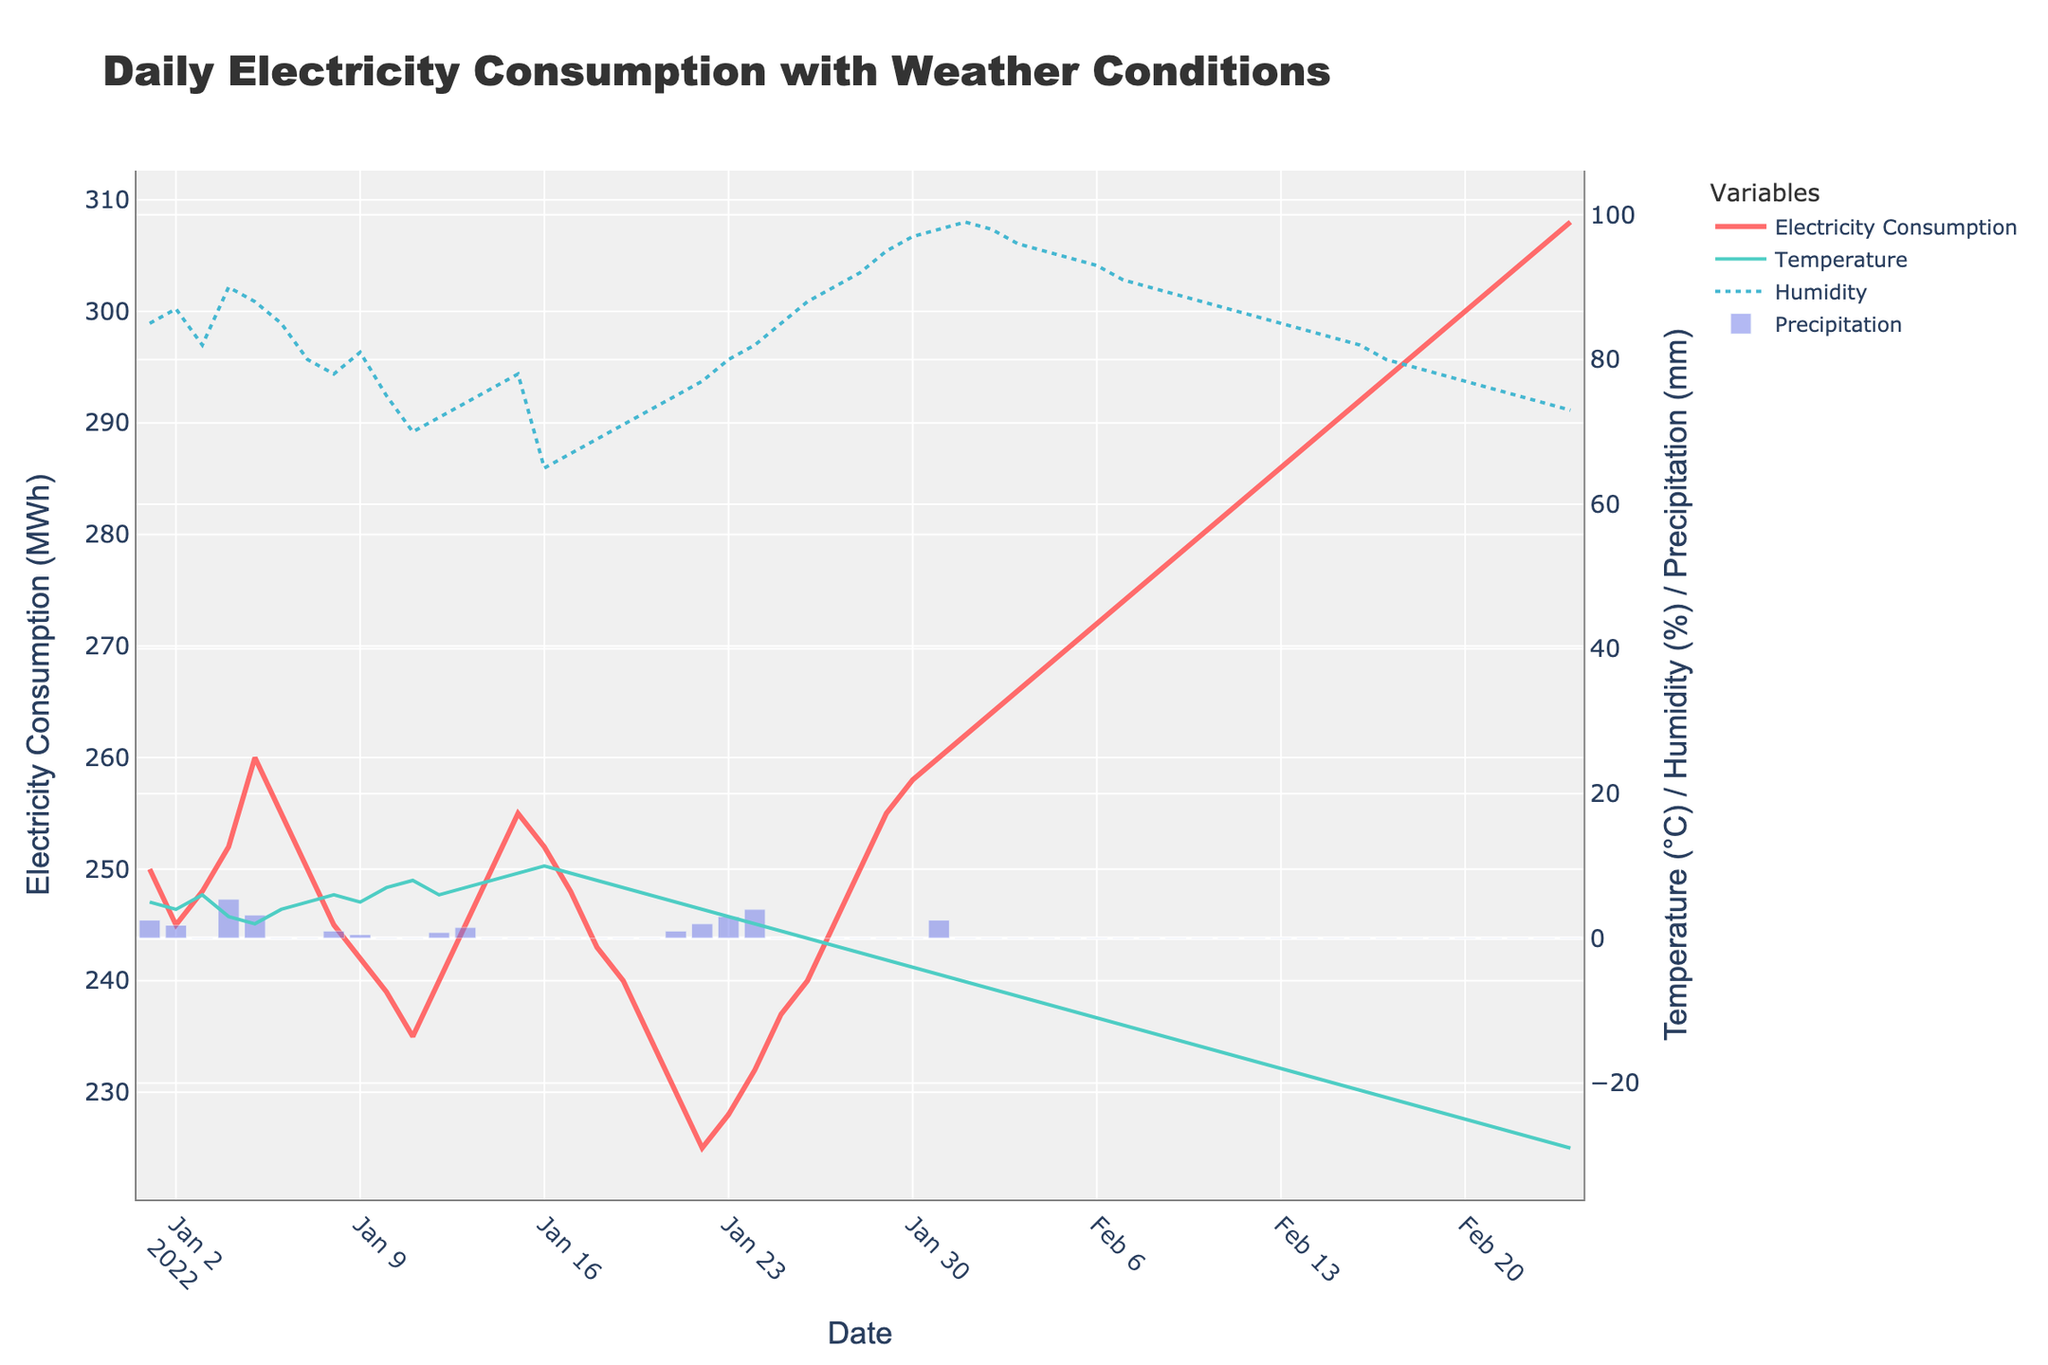What is the title of the plot? The plot's title is usually located at the top and is larger or bolded compared to other text. The title for this figure is clearly stated at the top.
Answer: Daily Electricity Consumption with Weather Conditions Which variable has a line color in red? The variable with the red line color is "Electricity Consumption," which can be identified by looking at the legend or associating the line color with the variable name in the figure.
Answer: Electricity Consumption How does electricity consumption change with temperature trends from January to February? Analyze the line for electricity consumption (red) and compare it with the temperature (green) trend line. As the temperature drops from January to February, the electricity consumption steadily increases.
Answer: Inversely related What days had the highest electricity consumption? Locate the specific points on the "Electricity Consumption" red line that peak. The highest peaks are observed in early February around the 8th and 15th.
Answer: Early February (around the 8th and 15th) What is the overall trend of humidity over the time period? Examine the dotted blue line representing humidity across the timeline from January to February. Humidity generally decreases from around 90% in January to about 75% or lower by mid-February.
Answer: Decreasing trend On February 1st, what is the approximate electricity consumption and temperature? Locate the vertical band for February 1st. The red line (electricity consumption) is at approximately 262 MWh, and the green line (temperature) is around -6°C.
Answer: 262 MWh and -6°C How does precipitation correlate with electricity consumption changes on January 31st? Check the vertical bar (light blue) for precipitation on this date and compare with electricity consumption. On January 31st, precipitation is 2.5 mm, and the electricity consumption is at a high value of 260 MWh, suggesting that precipitation might be influencing higher consumption levels.
Answer: Positive correlation on January 31st When was the temperature at its lowest and what was the electricity consumption on that day? Locate the lowest point in the green temperature line, which is around February 24th at approximately -29°C. The corresponding electricity consumption on that day is 308 MWh.
Answer: February 24th, 308 MWh What is the average temperature for the entire time period? To find the average temperature: Sum up the temperature values for all the days and divide by the number of days. Since detailed daily data isn't calculated here, refer to either provided summary statistics or assume steady trends. Sample estimation: halfway between 5°C and -29°C, adjust reasoning based on temperature spread.
Answer: ~ -12°C (approximate) Based on the plot, how does electricity consumption appear to react to changes in temperature and humidity together? Observe both the red (electricity consumption), green (temperature), and blue (humidity) lines together. Generally, lower temperatures and higher humidity tend to correlate with increased electricity consumption, particularly in colder months with humidity above 80%.
Answer: Higher consumption with low temperature and high humidity 